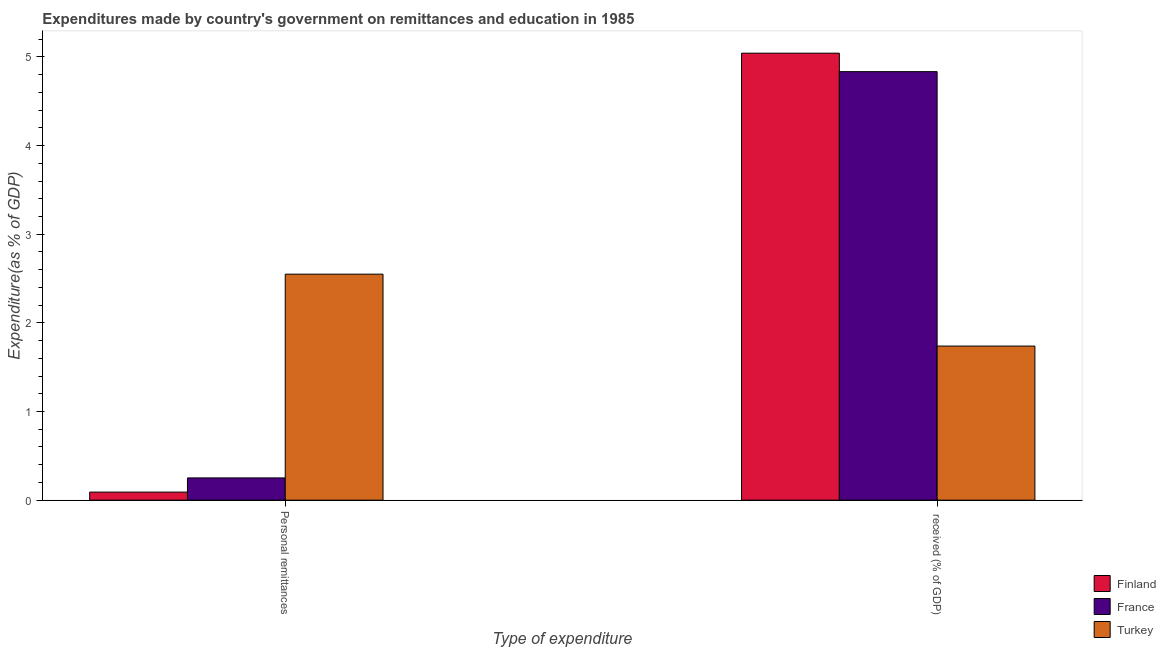How many different coloured bars are there?
Offer a very short reply. 3. How many groups of bars are there?
Give a very brief answer. 2. Are the number of bars per tick equal to the number of legend labels?
Provide a short and direct response. Yes. Are the number of bars on each tick of the X-axis equal?
Provide a succinct answer. Yes. What is the label of the 1st group of bars from the left?
Your response must be concise. Personal remittances. What is the expenditure in education in France?
Provide a succinct answer. 4.83. Across all countries, what is the maximum expenditure in education?
Provide a succinct answer. 5.04. Across all countries, what is the minimum expenditure in education?
Ensure brevity in your answer.  1.74. What is the total expenditure in personal remittances in the graph?
Keep it short and to the point. 2.89. What is the difference between the expenditure in education in France and that in Turkey?
Make the answer very short. 3.1. What is the difference between the expenditure in education in Finland and the expenditure in personal remittances in France?
Keep it short and to the point. 4.79. What is the average expenditure in personal remittances per country?
Make the answer very short. 0.96. What is the difference between the expenditure in education and expenditure in personal remittances in France?
Your answer should be very brief. 4.58. What is the ratio of the expenditure in education in Turkey to that in Finland?
Ensure brevity in your answer.  0.34. Is the expenditure in personal remittances in Turkey less than that in Finland?
Provide a succinct answer. No. In how many countries, is the expenditure in education greater than the average expenditure in education taken over all countries?
Offer a very short reply. 2. What does the 1st bar from the left in  received (% of GDP) represents?
Ensure brevity in your answer.  Finland. What does the 3rd bar from the right in Personal remittances represents?
Offer a very short reply. Finland. Are all the bars in the graph horizontal?
Offer a very short reply. No. How many countries are there in the graph?
Your answer should be very brief. 3. What is the difference between two consecutive major ticks on the Y-axis?
Your answer should be compact. 1. Are the values on the major ticks of Y-axis written in scientific E-notation?
Keep it short and to the point. No. Does the graph contain grids?
Provide a succinct answer. No. What is the title of the graph?
Keep it short and to the point. Expenditures made by country's government on remittances and education in 1985. Does "Micronesia" appear as one of the legend labels in the graph?
Offer a terse response. No. What is the label or title of the X-axis?
Make the answer very short. Type of expenditure. What is the label or title of the Y-axis?
Your answer should be very brief. Expenditure(as % of GDP). What is the Expenditure(as % of GDP) of Finland in Personal remittances?
Provide a succinct answer. 0.09. What is the Expenditure(as % of GDP) of France in Personal remittances?
Your answer should be very brief. 0.25. What is the Expenditure(as % of GDP) in Turkey in Personal remittances?
Provide a succinct answer. 2.55. What is the Expenditure(as % of GDP) in Finland in  received (% of GDP)?
Ensure brevity in your answer.  5.04. What is the Expenditure(as % of GDP) in France in  received (% of GDP)?
Make the answer very short. 4.83. What is the Expenditure(as % of GDP) in Turkey in  received (% of GDP)?
Offer a terse response. 1.74. Across all Type of expenditure, what is the maximum Expenditure(as % of GDP) in Finland?
Your answer should be very brief. 5.04. Across all Type of expenditure, what is the maximum Expenditure(as % of GDP) of France?
Ensure brevity in your answer.  4.83. Across all Type of expenditure, what is the maximum Expenditure(as % of GDP) of Turkey?
Provide a succinct answer. 2.55. Across all Type of expenditure, what is the minimum Expenditure(as % of GDP) of Finland?
Your answer should be very brief. 0.09. Across all Type of expenditure, what is the minimum Expenditure(as % of GDP) of France?
Give a very brief answer. 0.25. Across all Type of expenditure, what is the minimum Expenditure(as % of GDP) in Turkey?
Provide a short and direct response. 1.74. What is the total Expenditure(as % of GDP) of Finland in the graph?
Your answer should be very brief. 5.13. What is the total Expenditure(as % of GDP) in France in the graph?
Offer a very short reply. 5.08. What is the total Expenditure(as % of GDP) in Turkey in the graph?
Your response must be concise. 4.29. What is the difference between the Expenditure(as % of GDP) in Finland in Personal remittances and that in  received (% of GDP)?
Your answer should be compact. -4.95. What is the difference between the Expenditure(as % of GDP) of France in Personal remittances and that in  received (% of GDP)?
Provide a short and direct response. -4.58. What is the difference between the Expenditure(as % of GDP) in Turkey in Personal remittances and that in  received (% of GDP)?
Your answer should be compact. 0.81. What is the difference between the Expenditure(as % of GDP) of Finland in Personal remittances and the Expenditure(as % of GDP) of France in  received (% of GDP)?
Provide a short and direct response. -4.74. What is the difference between the Expenditure(as % of GDP) in Finland in Personal remittances and the Expenditure(as % of GDP) in Turkey in  received (% of GDP)?
Provide a short and direct response. -1.65. What is the difference between the Expenditure(as % of GDP) of France in Personal remittances and the Expenditure(as % of GDP) of Turkey in  received (% of GDP)?
Your response must be concise. -1.49. What is the average Expenditure(as % of GDP) in Finland per Type of expenditure?
Offer a terse response. 2.57. What is the average Expenditure(as % of GDP) in France per Type of expenditure?
Ensure brevity in your answer.  2.54. What is the average Expenditure(as % of GDP) of Turkey per Type of expenditure?
Provide a short and direct response. 2.14. What is the difference between the Expenditure(as % of GDP) in Finland and Expenditure(as % of GDP) in France in Personal remittances?
Provide a short and direct response. -0.16. What is the difference between the Expenditure(as % of GDP) of Finland and Expenditure(as % of GDP) of Turkey in Personal remittances?
Your answer should be compact. -2.46. What is the difference between the Expenditure(as % of GDP) of France and Expenditure(as % of GDP) of Turkey in Personal remittances?
Your answer should be compact. -2.3. What is the difference between the Expenditure(as % of GDP) of Finland and Expenditure(as % of GDP) of France in  received (% of GDP)?
Make the answer very short. 0.21. What is the difference between the Expenditure(as % of GDP) of Finland and Expenditure(as % of GDP) of Turkey in  received (% of GDP)?
Your response must be concise. 3.3. What is the difference between the Expenditure(as % of GDP) of France and Expenditure(as % of GDP) of Turkey in  received (% of GDP)?
Your answer should be very brief. 3.1. What is the ratio of the Expenditure(as % of GDP) of Finland in Personal remittances to that in  received (% of GDP)?
Your answer should be compact. 0.02. What is the ratio of the Expenditure(as % of GDP) of France in Personal remittances to that in  received (% of GDP)?
Your answer should be compact. 0.05. What is the ratio of the Expenditure(as % of GDP) of Turkey in Personal remittances to that in  received (% of GDP)?
Your answer should be compact. 1.47. What is the difference between the highest and the second highest Expenditure(as % of GDP) in Finland?
Make the answer very short. 4.95. What is the difference between the highest and the second highest Expenditure(as % of GDP) in France?
Give a very brief answer. 4.58. What is the difference between the highest and the second highest Expenditure(as % of GDP) in Turkey?
Provide a short and direct response. 0.81. What is the difference between the highest and the lowest Expenditure(as % of GDP) in Finland?
Your answer should be compact. 4.95. What is the difference between the highest and the lowest Expenditure(as % of GDP) of France?
Offer a very short reply. 4.58. What is the difference between the highest and the lowest Expenditure(as % of GDP) of Turkey?
Your answer should be compact. 0.81. 